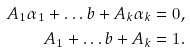<formula> <loc_0><loc_0><loc_500><loc_500>A _ { 1 } \alpha _ { 1 } + \dots b + A _ { k } \alpha _ { k } & = 0 , \\ A _ { 1 } + \dots b + A _ { k } & = 1 .</formula> 